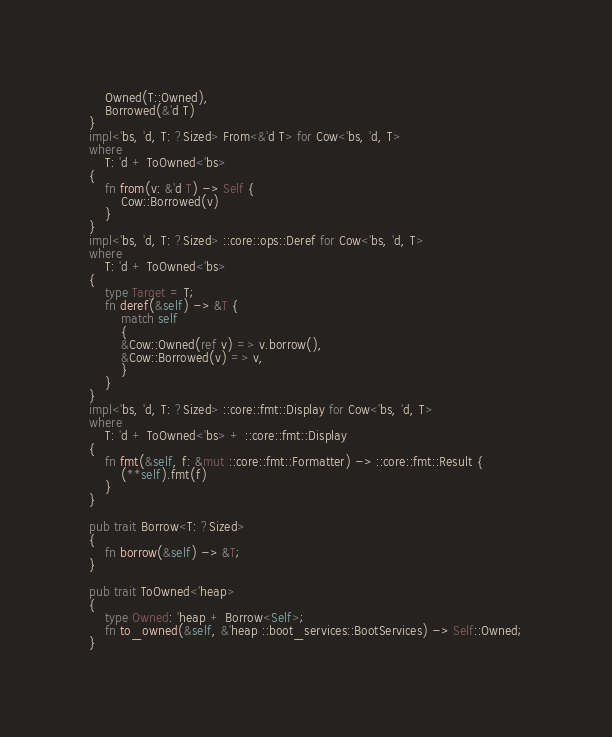<code> <loc_0><loc_0><loc_500><loc_500><_Rust_>	Owned(T::Owned),
	Borrowed(&'d T)
}
impl<'bs, 'd, T: ?Sized> From<&'d T> for Cow<'bs, 'd, T>
where
	T: 'd + ToOwned<'bs>
{
	fn from(v: &'d T) -> Self {
		Cow::Borrowed(v)
	}
}
impl<'bs, 'd, T: ?Sized> ::core::ops::Deref for Cow<'bs, 'd, T>
where
	T: 'd + ToOwned<'bs>
{
	type Target = T;
	fn deref(&self) -> &T {
		match self
		{
		&Cow::Owned(ref v) => v.borrow(),
		&Cow::Borrowed(v) => v,
		}
	}
}
impl<'bs, 'd, T: ?Sized> ::core::fmt::Display for Cow<'bs, 'd, T>
where
	T: 'd + ToOwned<'bs> + ::core::fmt::Display
{
	fn fmt(&self, f: &mut ::core::fmt::Formatter) -> ::core::fmt::Result {
		(**self).fmt(f)
	}
}

pub trait Borrow<T: ?Sized>
{
	fn borrow(&self) -> &T;
}

pub trait ToOwned<'heap>
{
	type Owned: 'heap + Borrow<Self>;
	fn to_owned(&self, &'heap ::boot_services::BootServices) -> Self::Owned;
}
</code> 